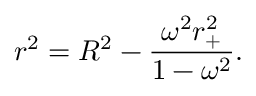Convert formula to latex. <formula><loc_0><loc_0><loc_500><loc_500>r ^ { 2 } = R ^ { 2 } - \frac { \omega ^ { 2 } r _ { + } ^ { 2 } } { 1 - \omega ^ { 2 } } .</formula> 